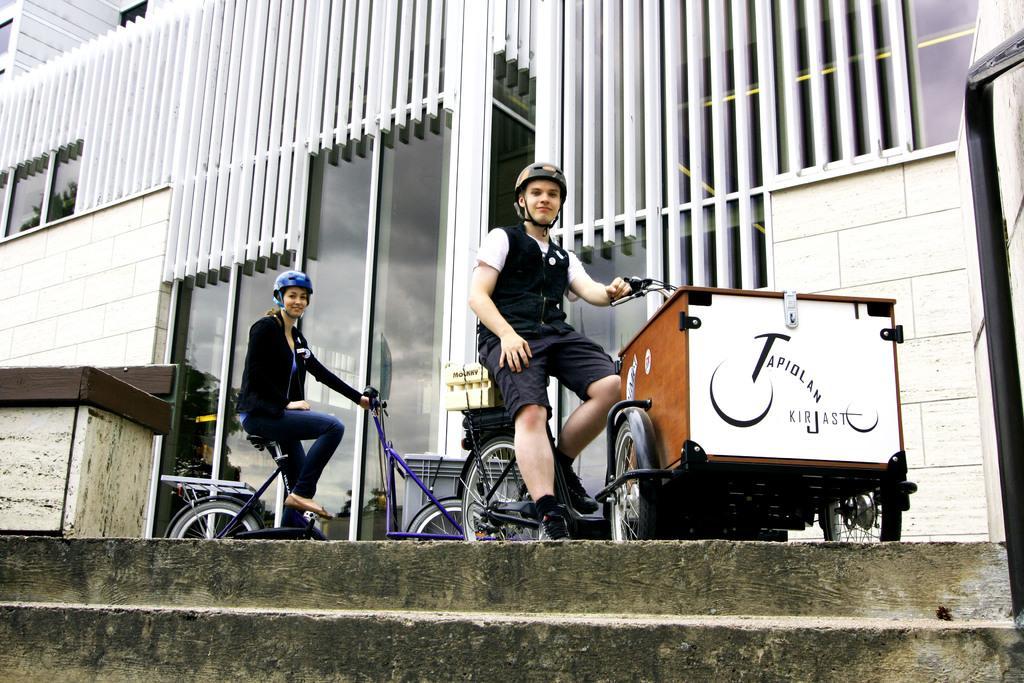Please provide a concise description of this image. Here there are steps and the person sitting on a vehicle. He is wearing a helmet. behind him there is a girl behind her there is a glass wall. 